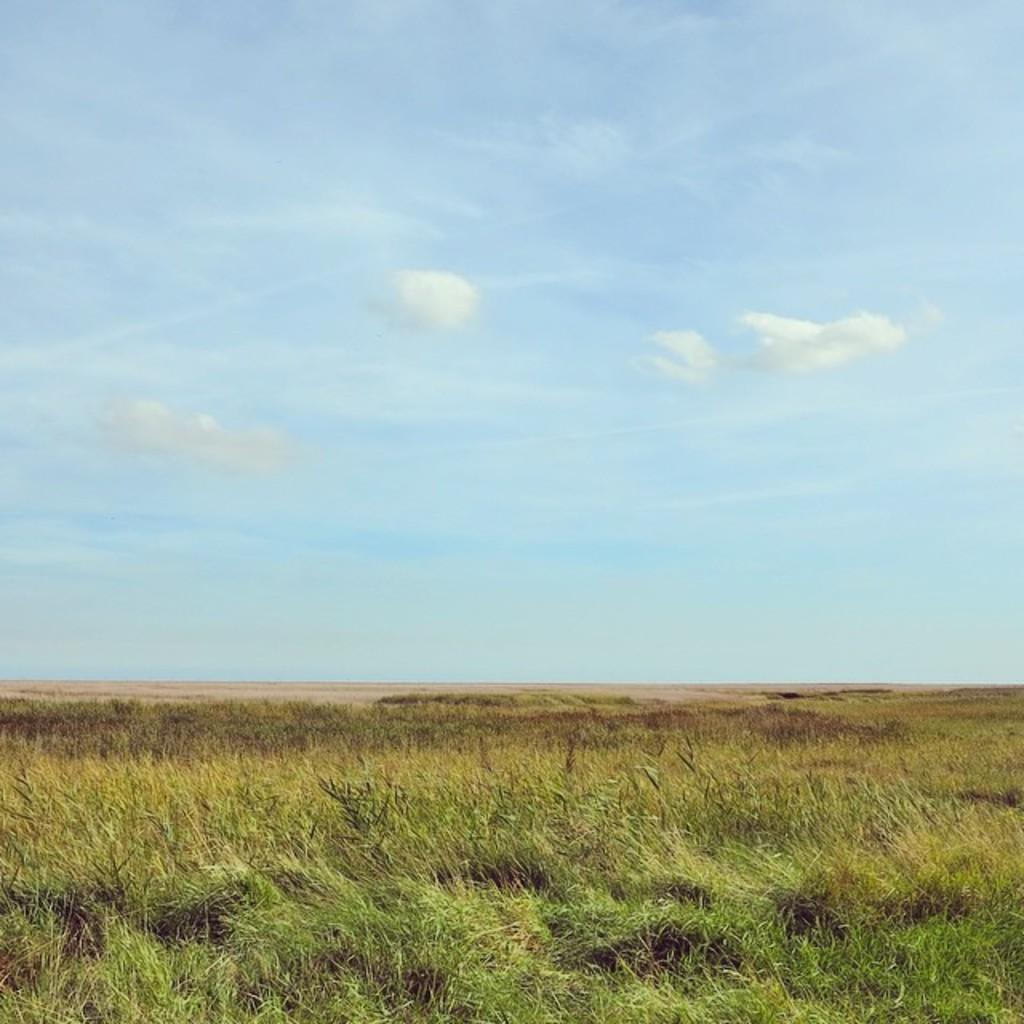Where was the image taken? The image was taken outside. What can be seen growing in the image? There are plants in the image. What material is present in the image? There is glass in the image. What is visible in the background of the image? The sky is visible in the image. What can be observed in the sky? Clouds are present in the sky. What type of steel structure can be seen in the image? There is no steel structure present in the image. What game is being played in the image? There is no game being played in the image. 